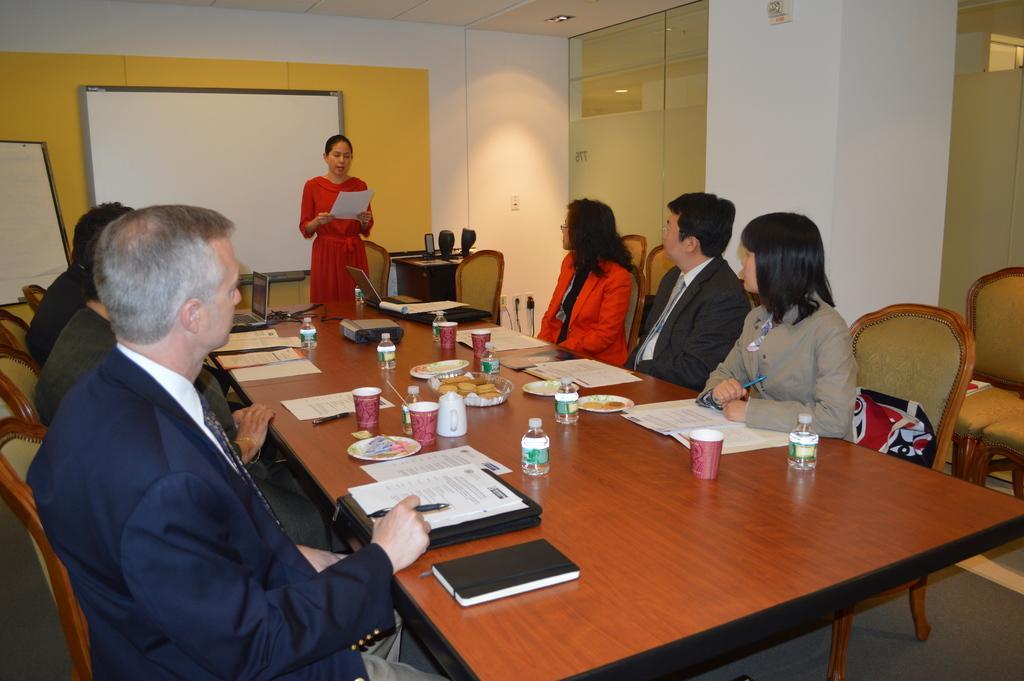How would you summarize this image in a sentence or two? This image is clicked in conference room. On the right there are three people sitting on the chair. In the middle there is a woman she is speaking something. On the left there are three people. In the background there is white board ,table and chairs. 